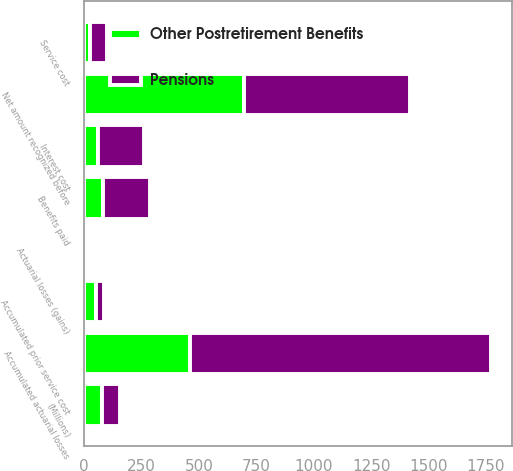Convert chart. <chart><loc_0><loc_0><loc_500><loc_500><stacked_bar_chart><ecel><fcel>(Millions)<fcel>Service cost<fcel>Interest cost<fcel>Actuarial losses (gains)<fcel>Benefits paid<fcel>Accumulated actuarial losses<fcel>Accumulated prior service cost<fcel>Net amount recognized before<nl><fcel>Pensions<fcel>79<fcel>74<fcel>197<fcel>10<fcel>203<fcel>1313<fcel>37<fcel>720<nl><fcel>Other Postretirement Benefits<fcel>79<fcel>27<fcel>62<fcel>7<fcel>84<fcel>460<fcel>51<fcel>698<nl></chart> 